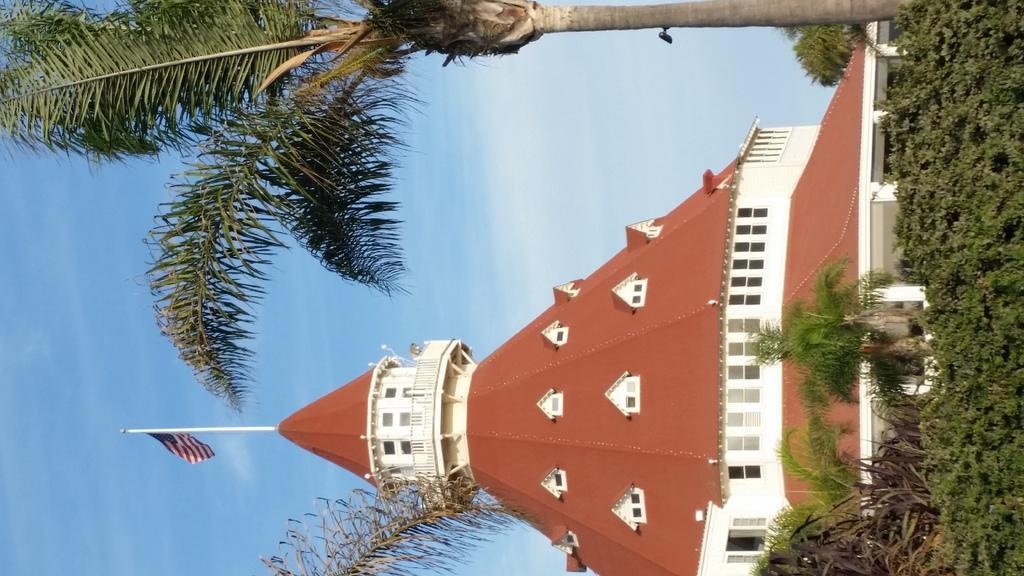Could you give a brief overview of what you see in this image? In this image I can see a building which is brown and cream in color and I can see a flag on the top of the building. I can see few trees which are green and brown in color and in the background I can see the sky. 